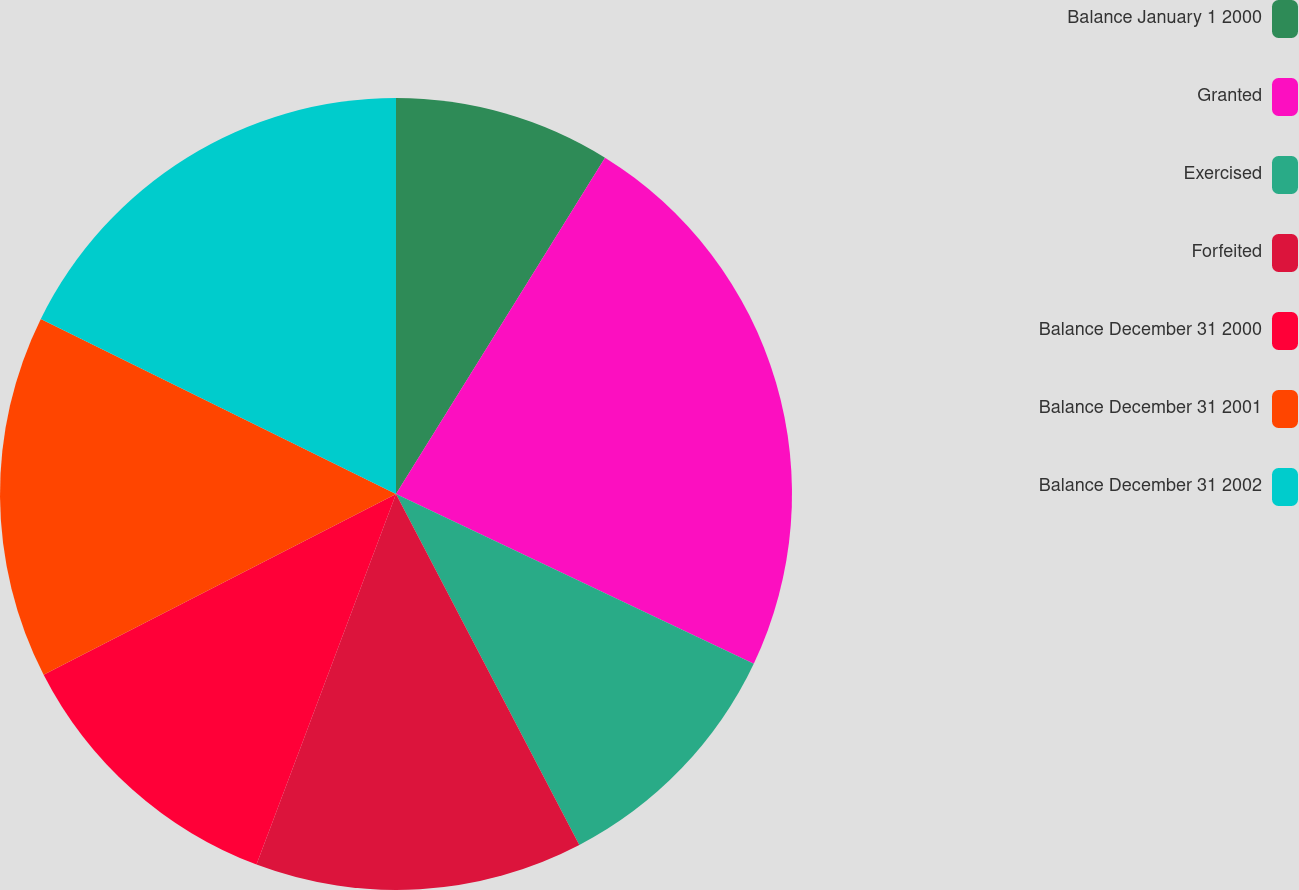<chart> <loc_0><loc_0><loc_500><loc_500><pie_chart><fcel>Balance January 1 2000<fcel>Granted<fcel>Exercised<fcel>Forfeited<fcel>Balance December 31 2000<fcel>Balance December 31 2001<fcel>Balance December 31 2002<nl><fcel>8.85%<fcel>23.2%<fcel>10.29%<fcel>13.39%<fcel>11.73%<fcel>14.83%<fcel>17.71%<nl></chart> 